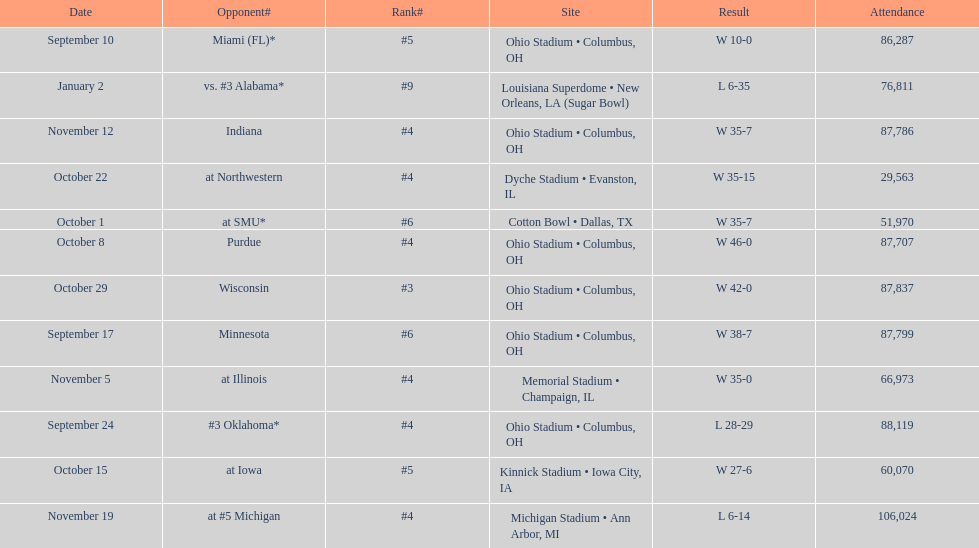What is the difference between the number of wins and the number of losses? 6. 